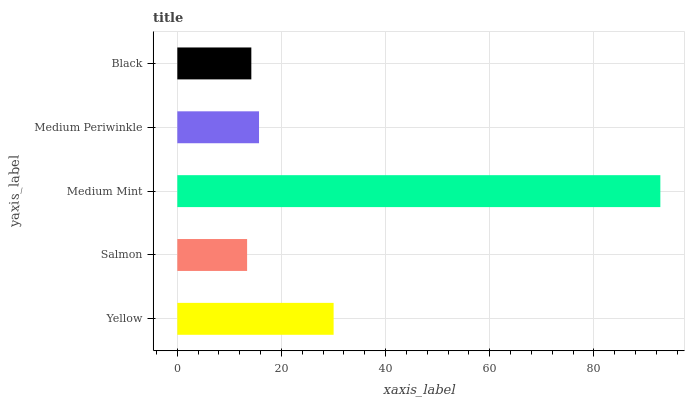Is Salmon the minimum?
Answer yes or no. Yes. Is Medium Mint the maximum?
Answer yes or no. Yes. Is Medium Mint the minimum?
Answer yes or no. No. Is Salmon the maximum?
Answer yes or no. No. Is Medium Mint greater than Salmon?
Answer yes or no. Yes. Is Salmon less than Medium Mint?
Answer yes or no. Yes. Is Salmon greater than Medium Mint?
Answer yes or no. No. Is Medium Mint less than Salmon?
Answer yes or no. No. Is Medium Periwinkle the high median?
Answer yes or no. Yes. Is Medium Periwinkle the low median?
Answer yes or no. Yes. Is Black the high median?
Answer yes or no. No. Is Medium Mint the low median?
Answer yes or no. No. 